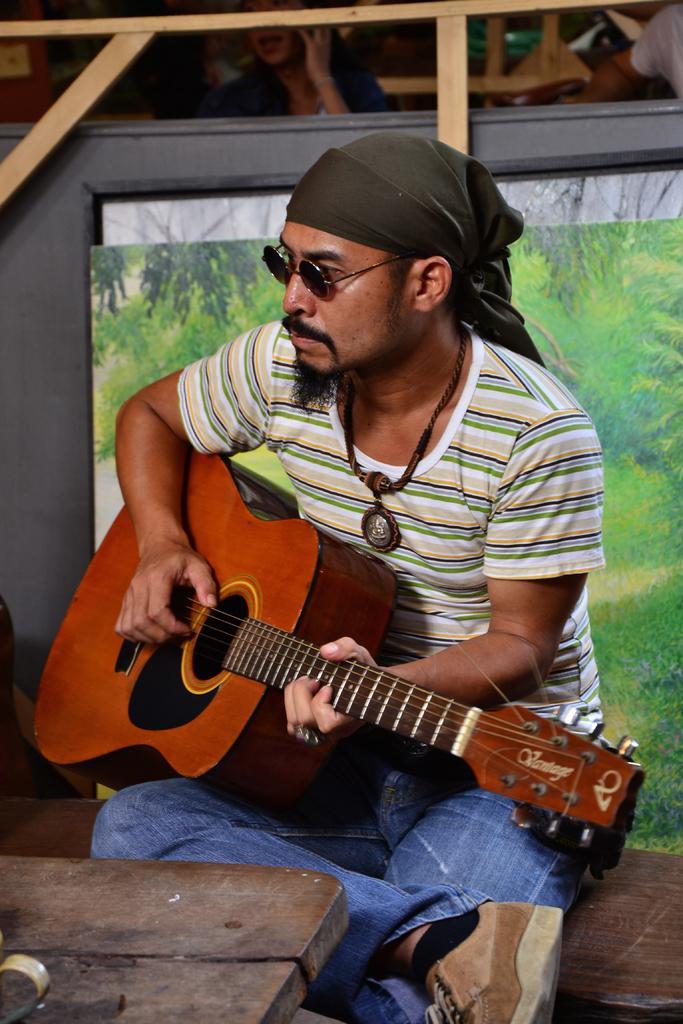Could you give a brief overview of what you see in this image? This is the picture of a person wearing green, white, black shirt and blue pant holding a musical instrument and playing it. 